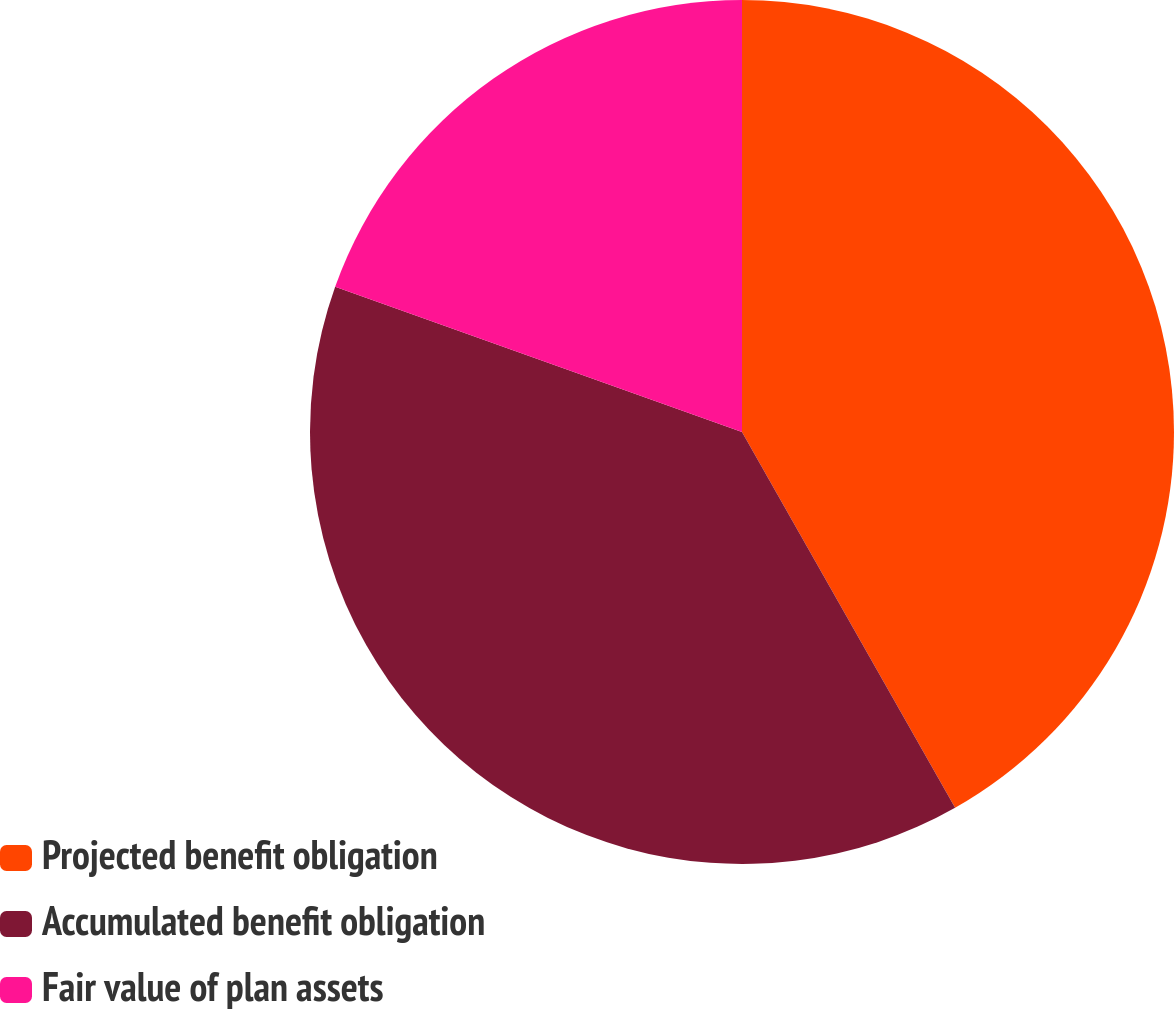Convert chart to OTSL. <chart><loc_0><loc_0><loc_500><loc_500><pie_chart><fcel>Projected benefit obligation<fcel>Accumulated benefit obligation<fcel>Fair value of plan assets<nl><fcel>41.79%<fcel>38.67%<fcel>19.54%<nl></chart> 